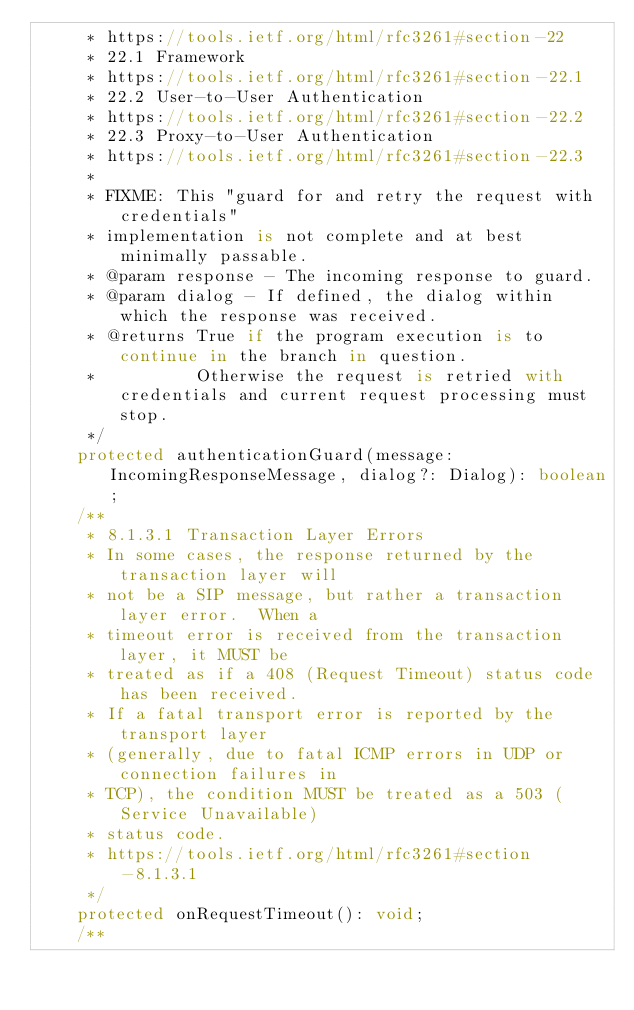<code> <loc_0><loc_0><loc_500><loc_500><_TypeScript_>     * https://tools.ietf.org/html/rfc3261#section-22
     * 22.1 Framework
     * https://tools.ietf.org/html/rfc3261#section-22.1
     * 22.2 User-to-User Authentication
     * https://tools.ietf.org/html/rfc3261#section-22.2
     * 22.3 Proxy-to-User Authentication
     * https://tools.ietf.org/html/rfc3261#section-22.3
     *
     * FIXME: This "guard for and retry the request with credentials"
     * implementation is not complete and at best minimally passable.
     * @param response - The incoming response to guard.
     * @param dialog - If defined, the dialog within which the response was received.
     * @returns True if the program execution is to continue in the branch in question.
     *          Otherwise the request is retried with credentials and current request processing must stop.
     */
    protected authenticationGuard(message: IncomingResponseMessage, dialog?: Dialog): boolean;
    /**
     * 8.1.3.1 Transaction Layer Errors
     * In some cases, the response returned by the transaction layer will
     * not be a SIP message, but rather a transaction layer error.  When a
     * timeout error is received from the transaction layer, it MUST be
     * treated as if a 408 (Request Timeout) status code has been received.
     * If a fatal transport error is reported by the transport layer
     * (generally, due to fatal ICMP errors in UDP or connection failures in
     * TCP), the condition MUST be treated as a 503 (Service Unavailable)
     * status code.
     * https://tools.ietf.org/html/rfc3261#section-8.1.3.1
     */
    protected onRequestTimeout(): void;
    /**</code> 